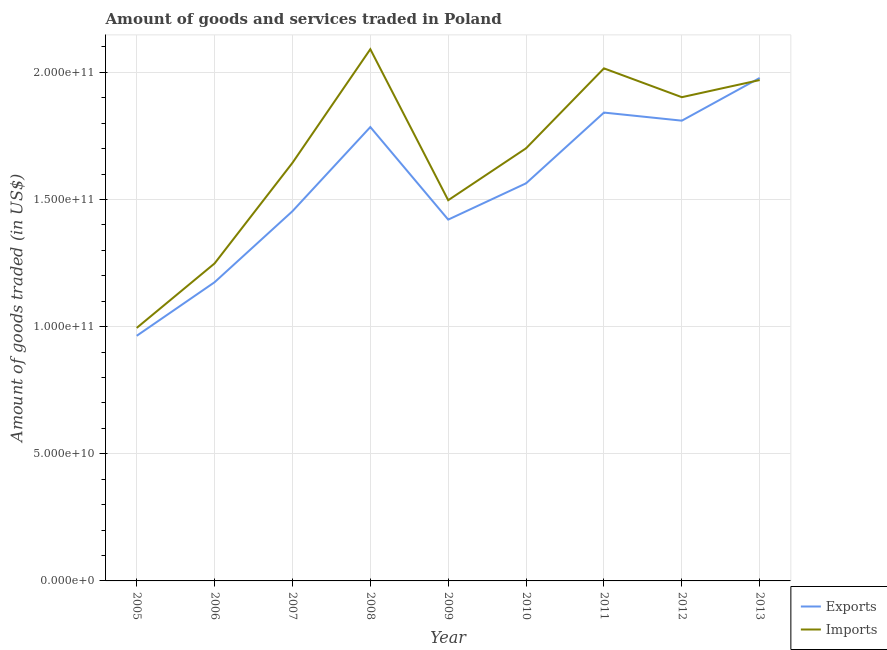Is the number of lines equal to the number of legend labels?
Make the answer very short. Yes. What is the amount of goods imported in 2005?
Keep it short and to the point. 9.95e+1. Across all years, what is the maximum amount of goods imported?
Provide a succinct answer. 2.09e+11. Across all years, what is the minimum amount of goods imported?
Give a very brief answer. 9.95e+1. What is the total amount of goods imported in the graph?
Offer a terse response. 1.51e+12. What is the difference between the amount of goods exported in 2012 and that in 2013?
Provide a succinct answer. -1.68e+1. What is the difference between the amount of goods exported in 2012 and the amount of goods imported in 2005?
Provide a short and direct response. 8.15e+1. What is the average amount of goods exported per year?
Give a very brief answer. 1.55e+11. In the year 2009, what is the difference between the amount of goods imported and amount of goods exported?
Offer a very short reply. 7.62e+09. What is the ratio of the amount of goods imported in 2006 to that in 2011?
Your response must be concise. 0.62. Is the difference between the amount of goods exported in 2005 and 2013 greater than the difference between the amount of goods imported in 2005 and 2013?
Make the answer very short. No. What is the difference between the highest and the second highest amount of goods exported?
Offer a terse response. 1.36e+1. What is the difference between the highest and the lowest amount of goods imported?
Provide a short and direct response. 1.10e+11. In how many years, is the amount of goods imported greater than the average amount of goods imported taken over all years?
Your response must be concise. 5. Is the amount of goods exported strictly greater than the amount of goods imported over the years?
Provide a short and direct response. No. How many lines are there?
Your response must be concise. 2. How many years are there in the graph?
Give a very brief answer. 9. What is the difference between two consecutive major ticks on the Y-axis?
Ensure brevity in your answer.  5.00e+1. Where does the legend appear in the graph?
Offer a terse response. Bottom right. What is the title of the graph?
Your answer should be compact. Amount of goods and services traded in Poland. What is the label or title of the Y-axis?
Provide a succinct answer. Amount of goods traded (in US$). What is the Amount of goods traded (in US$) in Exports in 2005?
Your answer should be compact. 9.64e+1. What is the Amount of goods traded (in US$) in Imports in 2005?
Your answer should be very brief. 9.95e+1. What is the Amount of goods traded (in US$) of Exports in 2006?
Offer a very short reply. 1.17e+11. What is the Amount of goods traded (in US$) of Imports in 2006?
Ensure brevity in your answer.  1.25e+11. What is the Amount of goods traded (in US$) of Exports in 2007?
Provide a short and direct response. 1.45e+11. What is the Amount of goods traded (in US$) of Imports in 2007?
Provide a short and direct response. 1.64e+11. What is the Amount of goods traded (in US$) of Exports in 2008?
Keep it short and to the point. 1.78e+11. What is the Amount of goods traded (in US$) in Imports in 2008?
Provide a short and direct response. 2.09e+11. What is the Amount of goods traded (in US$) in Exports in 2009?
Offer a very short reply. 1.42e+11. What is the Amount of goods traded (in US$) in Imports in 2009?
Your response must be concise. 1.50e+11. What is the Amount of goods traded (in US$) of Exports in 2010?
Provide a short and direct response. 1.56e+11. What is the Amount of goods traded (in US$) in Imports in 2010?
Ensure brevity in your answer.  1.70e+11. What is the Amount of goods traded (in US$) in Exports in 2011?
Offer a terse response. 1.84e+11. What is the Amount of goods traded (in US$) in Imports in 2011?
Provide a succinct answer. 2.02e+11. What is the Amount of goods traded (in US$) of Exports in 2012?
Provide a short and direct response. 1.81e+11. What is the Amount of goods traded (in US$) of Imports in 2012?
Ensure brevity in your answer.  1.90e+11. What is the Amount of goods traded (in US$) of Exports in 2013?
Your answer should be very brief. 1.98e+11. What is the Amount of goods traded (in US$) of Imports in 2013?
Provide a short and direct response. 1.97e+11. Across all years, what is the maximum Amount of goods traded (in US$) of Exports?
Make the answer very short. 1.98e+11. Across all years, what is the maximum Amount of goods traded (in US$) of Imports?
Provide a short and direct response. 2.09e+11. Across all years, what is the minimum Amount of goods traded (in US$) in Exports?
Offer a terse response. 9.64e+1. Across all years, what is the minimum Amount of goods traded (in US$) in Imports?
Your answer should be compact. 9.95e+1. What is the total Amount of goods traded (in US$) of Exports in the graph?
Provide a short and direct response. 1.40e+12. What is the total Amount of goods traded (in US$) in Imports in the graph?
Provide a short and direct response. 1.51e+12. What is the difference between the Amount of goods traded (in US$) of Exports in 2005 and that in 2006?
Give a very brief answer. -2.11e+1. What is the difference between the Amount of goods traded (in US$) of Imports in 2005 and that in 2006?
Offer a terse response. -2.54e+1. What is the difference between the Amount of goods traded (in US$) in Exports in 2005 and that in 2007?
Keep it short and to the point. -4.90e+1. What is the difference between the Amount of goods traded (in US$) in Imports in 2005 and that in 2007?
Offer a terse response. -6.49e+1. What is the difference between the Amount of goods traded (in US$) in Exports in 2005 and that in 2008?
Provide a short and direct response. -8.21e+1. What is the difference between the Amount of goods traded (in US$) in Imports in 2005 and that in 2008?
Make the answer very short. -1.10e+11. What is the difference between the Amount of goods traded (in US$) of Exports in 2005 and that in 2009?
Your answer should be very brief. -4.57e+1. What is the difference between the Amount of goods traded (in US$) in Imports in 2005 and that in 2009?
Provide a succinct answer. -5.02e+1. What is the difference between the Amount of goods traded (in US$) of Exports in 2005 and that in 2010?
Your answer should be compact. -6.00e+1. What is the difference between the Amount of goods traded (in US$) of Imports in 2005 and that in 2010?
Provide a short and direct response. -7.06e+1. What is the difference between the Amount of goods traded (in US$) of Exports in 2005 and that in 2011?
Ensure brevity in your answer.  -8.78e+1. What is the difference between the Amount of goods traded (in US$) in Imports in 2005 and that in 2011?
Offer a terse response. -1.02e+11. What is the difference between the Amount of goods traded (in US$) of Exports in 2005 and that in 2012?
Provide a short and direct response. -8.46e+1. What is the difference between the Amount of goods traded (in US$) of Imports in 2005 and that in 2012?
Ensure brevity in your answer.  -9.07e+1. What is the difference between the Amount of goods traded (in US$) in Exports in 2005 and that in 2013?
Your answer should be compact. -1.01e+11. What is the difference between the Amount of goods traded (in US$) of Imports in 2005 and that in 2013?
Provide a short and direct response. -9.75e+1. What is the difference between the Amount of goods traded (in US$) of Exports in 2006 and that in 2007?
Provide a short and direct response. -2.79e+1. What is the difference between the Amount of goods traded (in US$) in Imports in 2006 and that in 2007?
Ensure brevity in your answer.  -3.96e+1. What is the difference between the Amount of goods traded (in US$) in Exports in 2006 and that in 2008?
Ensure brevity in your answer.  -6.10e+1. What is the difference between the Amount of goods traded (in US$) of Imports in 2006 and that in 2008?
Provide a succinct answer. -8.42e+1. What is the difference between the Amount of goods traded (in US$) of Exports in 2006 and that in 2009?
Your answer should be compact. -2.46e+1. What is the difference between the Amount of goods traded (in US$) of Imports in 2006 and that in 2009?
Offer a very short reply. -2.49e+1. What is the difference between the Amount of goods traded (in US$) in Exports in 2006 and that in 2010?
Make the answer very short. -3.89e+1. What is the difference between the Amount of goods traded (in US$) in Imports in 2006 and that in 2010?
Make the answer very short. -4.53e+1. What is the difference between the Amount of goods traded (in US$) of Exports in 2006 and that in 2011?
Make the answer very short. -6.67e+1. What is the difference between the Amount of goods traded (in US$) of Imports in 2006 and that in 2011?
Your response must be concise. -7.67e+1. What is the difference between the Amount of goods traded (in US$) in Exports in 2006 and that in 2012?
Provide a short and direct response. -6.35e+1. What is the difference between the Amount of goods traded (in US$) of Imports in 2006 and that in 2012?
Make the answer very short. -6.54e+1. What is the difference between the Amount of goods traded (in US$) in Exports in 2006 and that in 2013?
Make the answer very short. -8.03e+1. What is the difference between the Amount of goods traded (in US$) in Imports in 2006 and that in 2013?
Give a very brief answer. -7.21e+1. What is the difference between the Amount of goods traded (in US$) of Exports in 2007 and that in 2008?
Offer a terse response. -3.31e+1. What is the difference between the Amount of goods traded (in US$) of Imports in 2007 and that in 2008?
Keep it short and to the point. -4.47e+1. What is the difference between the Amount of goods traded (in US$) of Exports in 2007 and that in 2009?
Keep it short and to the point. 3.30e+09. What is the difference between the Amount of goods traded (in US$) of Imports in 2007 and that in 2009?
Give a very brief answer. 1.47e+1. What is the difference between the Amount of goods traded (in US$) of Exports in 2007 and that in 2010?
Your response must be concise. -1.10e+1. What is the difference between the Amount of goods traded (in US$) in Imports in 2007 and that in 2010?
Keep it short and to the point. -5.72e+09. What is the difference between the Amount of goods traded (in US$) of Exports in 2007 and that in 2011?
Your answer should be compact. -3.88e+1. What is the difference between the Amount of goods traded (in US$) of Imports in 2007 and that in 2011?
Ensure brevity in your answer.  -3.71e+1. What is the difference between the Amount of goods traded (in US$) in Exports in 2007 and that in 2012?
Give a very brief answer. -3.56e+1. What is the difference between the Amount of goods traded (in US$) of Imports in 2007 and that in 2012?
Your answer should be compact. -2.58e+1. What is the difference between the Amount of goods traded (in US$) of Exports in 2007 and that in 2013?
Offer a terse response. -5.24e+1. What is the difference between the Amount of goods traded (in US$) of Imports in 2007 and that in 2013?
Your answer should be very brief. -3.26e+1. What is the difference between the Amount of goods traded (in US$) in Exports in 2008 and that in 2009?
Keep it short and to the point. 3.64e+1. What is the difference between the Amount of goods traded (in US$) in Imports in 2008 and that in 2009?
Your answer should be compact. 5.94e+1. What is the difference between the Amount of goods traded (in US$) in Exports in 2008 and that in 2010?
Offer a very short reply. 2.21e+1. What is the difference between the Amount of goods traded (in US$) in Imports in 2008 and that in 2010?
Offer a terse response. 3.90e+1. What is the difference between the Amount of goods traded (in US$) in Exports in 2008 and that in 2011?
Offer a terse response. -5.69e+09. What is the difference between the Amount of goods traded (in US$) in Imports in 2008 and that in 2011?
Offer a very short reply. 7.54e+09. What is the difference between the Amount of goods traded (in US$) in Exports in 2008 and that in 2012?
Provide a succinct answer. -2.51e+09. What is the difference between the Amount of goods traded (in US$) of Imports in 2008 and that in 2012?
Provide a succinct answer. 1.89e+1. What is the difference between the Amount of goods traded (in US$) of Exports in 2008 and that in 2013?
Provide a succinct answer. -1.93e+1. What is the difference between the Amount of goods traded (in US$) of Imports in 2008 and that in 2013?
Provide a succinct answer. 1.21e+1. What is the difference between the Amount of goods traded (in US$) of Exports in 2009 and that in 2010?
Make the answer very short. -1.43e+1. What is the difference between the Amount of goods traded (in US$) in Imports in 2009 and that in 2010?
Ensure brevity in your answer.  -2.04e+1. What is the difference between the Amount of goods traded (in US$) in Exports in 2009 and that in 2011?
Your response must be concise. -4.21e+1. What is the difference between the Amount of goods traded (in US$) of Imports in 2009 and that in 2011?
Offer a terse response. -5.18e+1. What is the difference between the Amount of goods traded (in US$) of Exports in 2009 and that in 2012?
Provide a succinct answer. -3.89e+1. What is the difference between the Amount of goods traded (in US$) in Imports in 2009 and that in 2012?
Keep it short and to the point. -4.05e+1. What is the difference between the Amount of goods traded (in US$) in Exports in 2009 and that in 2013?
Keep it short and to the point. -5.57e+1. What is the difference between the Amount of goods traded (in US$) in Imports in 2009 and that in 2013?
Make the answer very short. -4.73e+1. What is the difference between the Amount of goods traded (in US$) in Exports in 2010 and that in 2011?
Your answer should be very brief. -2.78e+1. What is the difference between the Amount of goods traded (in US$) in Imports in 2010 and that in 2011?
Keep it short and to the point. -3.14e+1. What is the difference between the Amount of goods traded (in US$) in Exports in 2010 and that in 2012?
Your answer should be very brief. -2.46e+1. What is the difference between the Amount of goods traded (in US$) of Imports in 2010 and that in 2012?
Provide a succinct answer. -2.01e+1. What is the difference between the Amount of goods traded (in US$) in Exports in 2010 and that in 2013?
Provide a short and direct response. -4.14e+1. What is the difference between the Amount of goods traded (in US$) in Imports in 2010 and that in 2013?
Keep it short and to the point. -2.68e+1. What is the difference between the Amount of goods traded (in US$) of Exports in 2011 and that in 2012?
Your answer should be compact. 3.18e+09. What is the difference between the Amount of goods traded (in US$) in Imports in 2011 and that in 2012?
Ensure brevity in your answer.  1.13e+1. What is the difference between the Amount of goods traded (in US$) of Exports in 2011 and that in 2013?
Ensure brevity in your answer.  -1.36e+1. What is the difference between the Amount of goods traded (in US$) of Imports in 2011 and that in 2013?
Make the answer very short. 4.60e+09. What is the difference between the Amount of goods traded (in US$) in Exports in 2012 and that in 2013?
Ensure brevity in your answer.  -1.68e+1. What is the difference between the Amount of goods traded (in US$) of Imports in 2012 and that in 2013?
Your response must be concise. -6.74e+09. What is the difference between the Amount of goods traded (in US$) of Exports in 2005 and the Amount of goods traded (in US$) of Imports in 2006?
Your response must be concise. -2.85e+1. What is the difference between the Amount of goods traded (in US$) of Exports in 2005 and the Amount of goods traded (in US$) of Imports in 2007?
Make the answer very short. -6.80e+1. What is the difference between the Amount of goods traded (in US$) of Exports in 2005 and the Amount of goods traded (in US$) of Imports in 2008?
Provide a short and direct response. -1.13e+11. What is the difference between the Amount of goods traded (in US$) in Exports in 2005 and the Amount of goods traded (in US$) in Imports in 2009?
Offer a terse response. -5.33e+1. What is the difference between the Amount of goods traded (in US$) in Exports in 2005 and the Amount of goods traded (in US$) in Imports in 2010?
Ensure brevity in your answer.  -7.37e+1. What is the difference between the Amount of goods traded (in US$) of Exports in 2005 and the Amount of goods traded (in US$) of Imports in 2011?
Give a very brief answer. -1.05e+11. What is the difference between the Amount of goods traded (in US$) in Exports in 2005 and the Amount of goods traded (in US$) in Imports in 2012?
Your answer should be very brief. -9.38e+1. What is the difference between the Amount of goods traded (in US$) of Exports in 2005 and the Amount of goods traded (in US$) of Imports in 2013?
Make the answer very short. -1.01e+11. What is the difference between the Amount of goods traded (in US$) of Exports in 2006 and the Amount of goods traded (in US$) of Imports in 2007?
Your answer should be compact. -4.70e+1. What is the difference between the Amount of goods traded (in US$) of Exports in 2006 and the Amount of goods traded (in US$) of Imports in 2008?
Keep it short and to the point. -9.16e+1. What is the difference between the Amount of goods traded (in US$) in Exports in 2006 and the Amount of goods traded (in US$) in Imports in 2009?
Your answer should be compact. -3.23e+1. What is the difference between the Amount of goods traded (in US$) in Exports in 2006 and the Amount of goods traded (in US$) in Imports in 2010?
Offer a terse response. -5.27e+1. What is the difference between the Amount of goods traded (in US$) of Exports in 2006 and the Amount of goods traded (in US$) of Imports in 2011?
Your answer should be very brief. -8.41e+1. What is the difference between the Amount of goods traded (in US$) in Exports in 2006 and the Amount of goods traded (in US$) in Imports in 2012?
Ensure brevity in your answer.  -7.28e+1. What is the difference between the Amount of goods traded (in US$) of Exports in 2006 and the Amount of goods traded (in US$) of Imports in 2013?
Give a very brief answer. -7.95e+1. What is the difference between the Amount of goods traded (in US$) of Exports in 2007 and the Amount of goods traded (in US$) of Imports in 2008?
Give a very brief answer. -6.37e+1. What is the difference between the Amount of goods traded (in US$) of Exports in 2007 and the Amount of goods traded (in US$) of Imports in 2009?
Ensure brevity in your answer.  -4.32e+09. What is the difference between the Amount of goods traded (in US$) in Exports in 2007 and the Amount of goods traded (in US$) in Imports in 2010?
Keep it short and to the point. -2.47e+1. What is the difference between the Amount of goods traded (in US$) of Exports in 2007 and the Amount of goods traded (in US$) of Imports in 2011?
Your response must be concise. -5.62e+1. What is the difference between the Amount of goods traded (in US$) of Exports in 2007 and the Amount of goods traded (in US$) of Imports in 2012?
Your response must be concise. -4.48e+1. What is the difference between the Amount of goods traded (in US$) of Exports in 2007 and the Amount of goods traded (in US$) of Imports in 2013?
Make the answer very short. -5.16e+1. What is the difference between the Amount of goods traded (in US$) of Exports in 2008 and the Amount of goods traded (in US$) of Imports in 2009?
Make the answer very short. 2.88e+1. What is the difference between the Amount of goods traded (in US$) in Exports in 2008 and the Amount of goods traded (in US$) in Imports in 2010?
Your answer should be very brief. 8.35e+09. What is the difference between the Amount of goods traded (in US$) of Exports in 2008 and the Amount of goods traded (in US$) of Imports in 2011?
Keep it short and to the point. -2.31e+1. What is the difference between the Amount of goods traded (in US$) in Exports in 2008 and the Amount of goods traded (in US$) in Imports in 2012?
Your answer should be very brief. -1.17e+1. What is the difference between the Amount of goods traded (in US$) in Exports in 2008 and the Amount of goods traded (in US$) in Imports in 2013?
Provide a succinct answer. -1.85e+1. What is the difference between the Amount of goods traded (in US$) in Exports in 2009 and the Amount of goods traded (in US$) in Imports in 2010?
Your answer should be compact. -2.80e+1. What is the difference between the Amount of goods traded (in US$) of Exports in 2009 and the Amount of goods traded (in US$) of Imports in 2011?
Your response must be concise. -5.95e+1. What is the difference between the Amount of goods traded (in US$) of Exports in 2009 and the Amount of goods traded (in US$) of Imports in 2012?
Provide a succinct answer. -4.81e+1. What is the difference between the Amount of goods traded (in US$) of Exports in 2009 and the Amount of goods traded (in US$) of Imports in 2013?
Your response must be concise. -5.49e+1. What is the difference between the Amount of goods traded (in US$) of Exports in 2010 and the Amount of goods traded (in US$) of Imports in 2011?
Offer a very short reply. -4.52e+1. What is the difference between the Amount of goods traded (in US$) in Exports in 2010 and the Amount of goods traded (in US$) in Imports in 2012?
Offer a very short reply. -3.39e+1. What is the difference between the Amount of goods traded (in US$) of Exports in 2010 and the Amount of goods traded (in US$) of Imports in 2013?
Make the answer very short. -4.06e+1. What is the difference between the Amount of goods traded (in US$) of Exports in 2011 and the Amount of goods traded (in US$) of Imports in 2012?
Offer a terse response. -6.05e+09. What is the difference between the Amount of goods traded (in US$) of Exports in 2011 and the Amount of goods traded (in US$) of Imports in 2013?
Provide a short and direct response. -1.28e+1. What is the difference between the Amount of goods traded (in US$) of Exports in 2012 and the Amount of goods traded (in US$) of Imports in 2013?
Offer a very short reply. -1.60e+1. What is the average Amount of goods traded (in US$) of Exports per year?
Ensure brevity in your answer.  1.55e+11. What is the average Amount of goods traded (in US$) of Imports per year?
Offer a terse response. 1.67e+11. In the year 2005, what is the difference between the Amount of goods traded (in US$) of Exports and Amount of goods traded (in US$) of Imports?
Your answer should be very brief. -3.10e+09. In the year 2006, what is the difference between the Amount of goods traded (in US$) in Exports and Amount of goods traded (in US$) in Imports?
Offer a very short reply. -7.39e+09. In the year 2007, what is the difference between the Amount of goods traded (in US$) of Exports and Amount of goods traded (in US$) of Imports?
Your answer should be very brief. -1.90e+1. In the year 2008, what is the difference between the Amount of goods traded (in US$) in Exports and Amount of goods traded (in US$) in Imports?
Offer a terse response. -3.06e+1. In the year 2009, what is the difference between the Amount of goods traded (in US$) in Exports and Amount of goods traded (in US$) in Imports?
Offer a very short reply. -7.62e+09. In the year 2010, what is the difference between the Amount of goods traded (in US$) in Exports and Amount of goods traded (in US$) in Imports?
Make the answer very short. -1.38e+1. In the year 2011, what is the difference between the Amount of goods traded (in US$) of Exports and Amount of goods traded (in US$) of Imports?
Your response must be concise. -1.74e+1. In the year 2012, what is the difference between the Amount of goods traded (in US$) in Exports and Amount of goods traded (in US$) in Imports?
Your answer should be very brief. -9.23e+09. In the year 2013, what is the difference between the Amount of goods traded (in US$) of Exports and Amount of goods traded (in US$) of Imports?
Your answer should be very brief. 8.33e+08. What is the ratio of the Amount of goods traded (in US$) in Exports in 2005 to that in 2006?
Give a very brief answer. 0.82. What is the ratio of the Amount of goods traded (in US$) in Imports in 2005 to that in 2006?
Give a very brief answer. 0.8. What is the ratio of the Amount of goods traded (in US$) in Exports in 2005 to that in 2007?
Provide a short and direct response. 0.66. What is the ratio of the Amount of goods traded (in US$) of Imports in 2005 to that in 2007?
Give a very brief answer. 0.61. What is the ratio of the Amount of goods traded (in US$) in Exports in 2005 to that in 2008?
Keep it short and to the point. 0.54. What is the ratio of the Amount of goods traded (in US$) in Imports in 2005 to that in 2008?
Your answer should be very brief. 0.48. What is the ratio of the Amount of goods traded (in US$) of Exports in 2005 to that in 2009?
Your answer should be compact. 0.68. What is the ratio of the Amount of goods traded (in US$) in Imports in 2005 to that in 2009?
Your response must be concise. 0.66. What is the ratio of the Amount of goods traded (in US$) of Exports in 2005 to that in 2010?
Give a very brief answer. 0.62. What is the ratio of the Amount of goods traded (in US$) of Imports in 2005 to that in 2010?
Your answer should be compact. 0.58. What is the ratio of the Amount of goods traded (in US$) in Exports in 2005 to that in 2011?
Your answer should be very brief. 0.52. What is the ratio of the Amount of goods traded (in US$) in Imports in 2005 to that in 2011?
Your answer should be compact. 0.49. What is the ratio of the Amount of goods traded (in US$) in Exports in 2005 to that in 2012?
Provide a short and direct response. 0.53. What is the ratio of the Amount of goods traded (in US$) in Imports in 2005 to that in 2012?
Your answer should be compact. 0.52. What is the ratio of the Amount of goods traded (in US$) in Exports in 2005 to that in 2013?
Your answer should be compact. 0.49. What is the ratio of the Amount of goods traded (in US$) in Imports in 2005 to that in 2013?
Your response must be concise. 0.51. What is the ratio of the Amount of goods traded (in US$) of Exports in 2006 to that in 2007?
Provide a succinct answer. 0.81. What is the ratio of the Amount of goods traded (in US$) in Imports in 2006 to that in 2007?
Give a very brief answer. 0.76. What is the ratio of the Amount of goods traded (in US$) of Exports in 2006 to that in 2008?
Your answer should be compact. 0.66. What is the ratio of the Amount of goods traded (in US$) of Imports in 2006 to that in 2008?
Make the answer very short. 0.6. What is the ratio of the Amount of goods traded (in US$) in Exports in 2006 to that in 2009?
Offer a very short reply. 0.83. What is the ratio of the Amount of goods traded (in US$) in Imports in 2006 to that in 2009?
Provide a short and direct response. 0.83. What is the ratio of the Amount of goods traded (in US$) in Exports in 2006 to that in 2010?
Your answer should be compact. 0.75. What is the ratio of the Amount of goods traded (in US$) in Imports in 2006 to that in 2010?
Ensure brevity in your answer.  0.73. What is the ratio of the Amount of goods traded (in US$) of Exports in 2006 to that in 2011?
Provide a succinct answer. 0.64. What is the ratio of the Amount of goods traded (in US$) in Imports in 2006 to that in 2011?
Give a very brief answer. 0.62. What is the ratio of the Amount of goods traded (in US$) of Exports in 2006 to that in 2012?
Provide a succinct answer. 0.65. What is the ratio of the Amount of goods traded (in US$) in Imports in 2006 to that in 2012?
Provide a succinct answer. 0.66. What is the ratio of the Amount of goods traded (in US$) of Exports in 2006 to that in 2013?
Keep it short and to the point. 0.59. What is the ratio of the Amount of goods traded (in US$) of Imports in 2006 to that in 2013?
Provide a short and direct response. 0.63. What is the ratio of the Amount of goods traded (in US$) in Exports in 2007 to that in 2008?
Offer a terse response. 0.81. What is the ratio of the Amount of goods traded (in US$) of Imports in 2007 to that in 2008?
Offer a very short reply. 0.79. What is the ratio of the Amount of goods traded (in US$) of Exports in 2007 to that in 2009?
Your answer should be compact. 1.02. What is the ratio of the Amount of goods traded (in US$) of Imports in 2007 to that in 2009?
Ensure brevity in your answer.  1.1. What is the ratio of the Amount of goods traded (in US$) of Exports in 2007 to that in 2010?
Your answer should be very brief. 0.93. What is the ratio of the Amount of goods traded (in US$) of Imports in 2007 to that in 2010?
Offer a very short reply. 0.97. What is the ratio of the Amount of goods traded (in US$) in Exports in 2007 to that in 2011?
Your answer should be compact. 0.79. What is the ratio of the Amount of goods traded (in US$) in Imports in 2007 to that in 2011?
Provide a short and direct response. 0.82. What is the ratio of the Amount of goods traded (in US$) in Exports in 2007 to that in 2012?
Offer a very short reply. 0.8. What is the ratio of the Amount of goods traded (in US$) in Imports in 2007 to that in 2012?
Provide a short and direct response. 0.86. What is the ratio of the Amount of goods traded (in US$) of Exports in 2007 to that in 2013?
Provide a short and direct response. 0.73. What is the ratio of the Amount of goods traded (in US$) of Imports in 2007 to that in 2013?
Give a very brief answer. 0.83. What is the ratio of the Amount of goods traded (in US$) of Exports in 2008 to that in 2009?
Give a very brief answer. 1.26. What is the ratio of the Amount of goods traded (in US$) in Imports in 2008 to that in 2009?
Provide a short and direct response. 1.4. What is the ratio of the Amount of goods traded (in US$) in Exports in 2008 to that in 2010?
Give a very brief answer. 1.14. What is the ratio of the Amount of goods traded (in US$) of Imports in 2008 to that in 2010?
Make the answer very short. 1.23. What is the ratio of the Amount of goods traded (in US$) in Exports in 2008 to that in 2011?
Keep it short and to the point. 0.97. What is the ratio of the Amount of goods traded (in US$) of Imports in 2008 to that in 2011?
Your response must be concise. 1.04. What is the ratio of the Amount of goods traded (in US$) in Exports in 2008 to that in 2012?
Provide a short and direct response. 0.99. What is the ratio of the Amount of goods traded (in US$) in Imports in 2008 to that in 2012?
Give a very brief answer. 1.1. What is the ratio of the Amount of goods traded (in US$) in Exports in 2008 to that in 2013?
Provide a short and direct response. 0.9. What is the ratio of the Amount of goods traded (in US$) in Imports in 2008 to that in 2013?
Ensure brevity in your answer.  1.06. What is the ratio of the Amount of goods traded (in US$) in Exports in 2009 to that in 2010?
Offer a very short reply. 0.91. What is the ratio of the Amount of goods traded (in US$) of Imports in 2009 to that in 2010?
Keep it short and to the point. 0.88. What is the ratio of the Amount of goods traded (in US$) of Exports in 2009 to that in 2011?
Provide a short and direct response. 0.77. What is the ratio of the Amount of goods traded (in US$) in Imports in 2009 to that in 2011?
Give a very brief answer. 0.74. What is the ratio of the Amount of goods traded (in US$) of Exports in 2009 to that in 2012?
Keep it short and to the point. 0.79. What is the ratio of the Amount of goods traded (in US$) in Imports in 2009 to that in 2012?
Make the answer very short. 0.79. What is the ratio of the Amount of goods traded (in US$) in Exports in 2009 to that in 2013?
Keep it short and to the point. 0.72. What is the ratio of the Amount of goods traded (in US$) in Imports in 2009 to that in 2013?
Provide a short and direct response. 0.76. What is the ratio of the Amount of goods traded (in US$) of Exports in 2010 to that in 2011?
Offer a terse response. 0.85. What is the ratio of the Amount of goods traded (in US$) of Imports in 2010 to that in 2011?
Your answer should be compact. 0.84. What is the ratio of the Amount of goods traded (in US$) of Exports in 2010 to that in 2012?
Give a very brief answer. 0.86. What is the ratio of the Amount of goods traded (in US$) in Imports in 2010 to that in 2012?
Your answer should be very brief. 0.89. What is the ratio of the Amount of goods traded (in US$) in Exports in 2010 to that in 2013?
Provide a succinct answer. 0.79. What is the ratio of the Amount of goods traded (in US$) in Imports in 2010 to that in 2013?
Keep it short and to the point. 0.86. What is the ratio of the Amount of goods traded (in US$) in Exports in 2011 to that in 2012?
Provide a short and direct response. 1.02. What is the ratio of the Amount of goods traded (in US$) in Imports in 2011 to that in 2012?
Make the answer very short. 1.06. What is the ratio of the Amount of goods traded (in US$) in Exports in 2011 to that in 2013?
Your answer should be very brief. 0.93. What is the ratio of the Amount of goods traded (in US$) of Imports in 2011 to that in 2013?
Ensure brevity in your answer.  1.02. What is the ratio of the Amount of goods traded (in US$) in Exports in 2012 to that in 2013?
Ensure brevity in your answer.  0.92. What is the ratio of the Amount of goods traded (in US$) in Imports in 2012 to that in 2013?
Provide a short and direct response. 0.97. What is the difference between the highest and the second highest Amount of goods traded (in US$) in Exports?
Provide a short and direct response. 1.36e+1. What is the difference between the highest and the second highest Amount of goods traded (in US$) of Imports?
Make the answer very short. 7.54e+09. What is the difference between the highest and the lowest Amount of goods traded (in US$) in Exports?
Make the answer very short. 1.01e+11. What is the difference between the highest and the lowest Amount of goods traded (in US$) of Imports?
Your answer should be compact. 1.10e+11. 